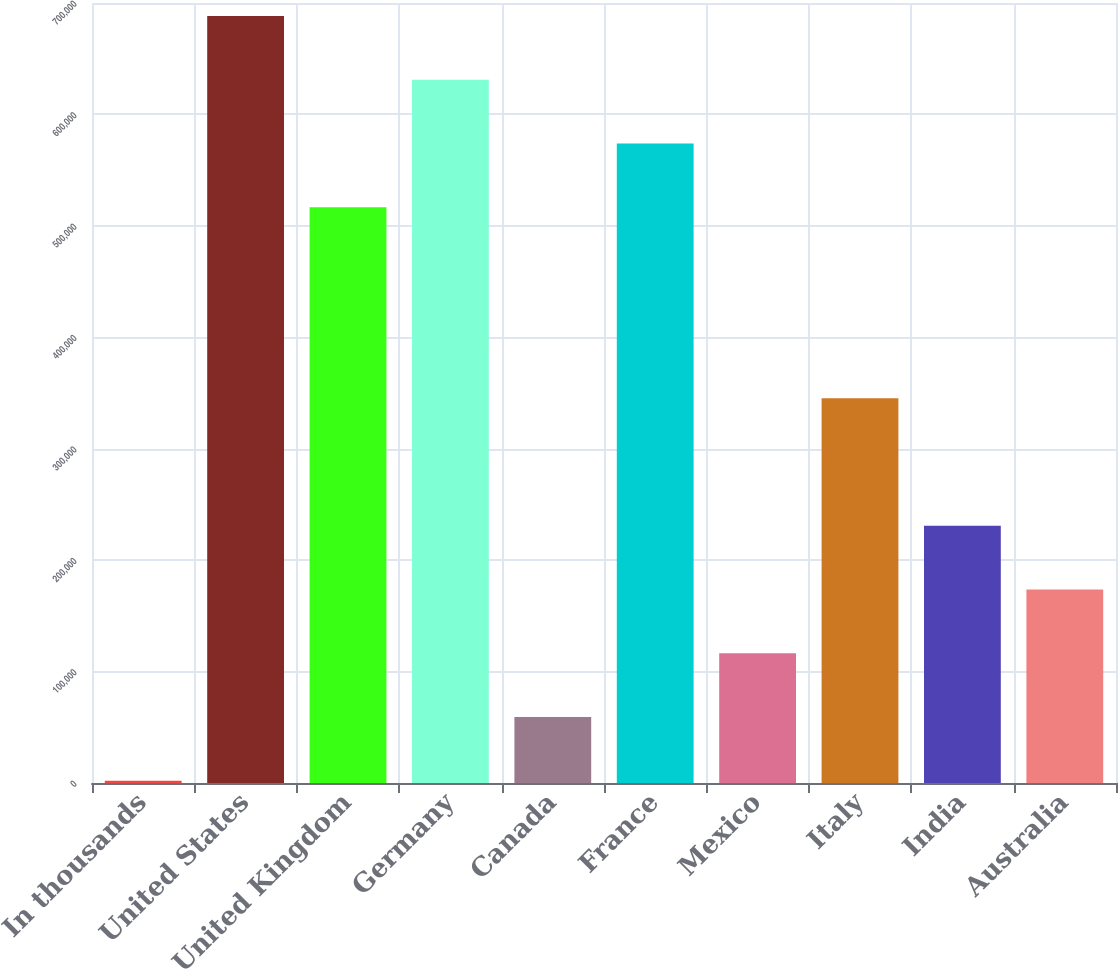<chart> <loc_0><loc_0><loc_500><loc_500><bar_chart><fcel>In thousands<fcel>United States<fcel>United Kingdom<fcel>Germany<fcel>Canada<fcel>France<fcel>Mexico<fcel>Italy<fcel>India<fcel>Australia<nl><fcel>2017<fcel>688363<fcel>516776<fcel>631168<fcel>59212.5<fcel>573972<fcel>116408<fcel>345190<fcel>230799<fcel>173604<nl></chart> 